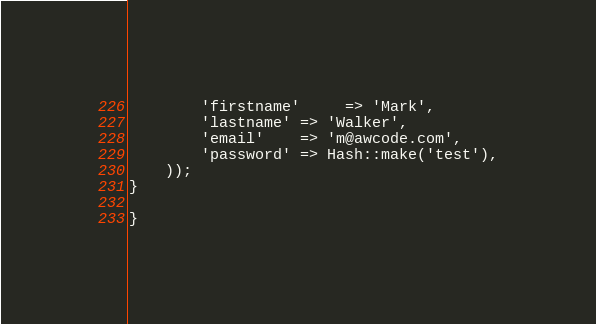Convert code to text. <code><loc_0><loc_0><loc_500><loc_500><_PHP_>        'firstname'     => 'Mark',
        'lastname' => 'Walker',
        'email'    => 'm@awcode.com',
        'password' => Hash::make('test'),
    ));
}

}
</code> 